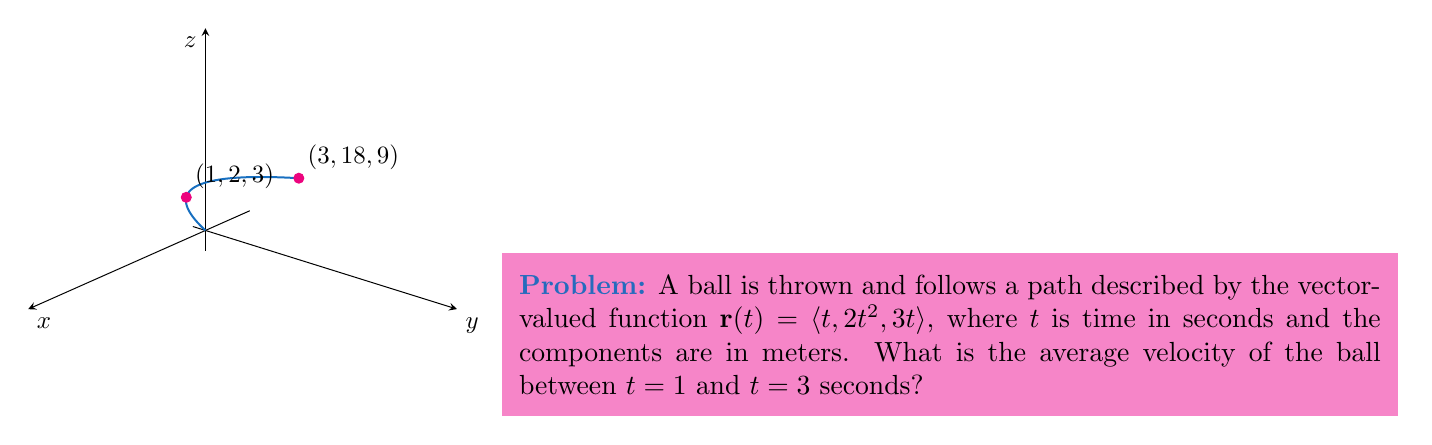Solve this math problem. To find the average velocity, we need to follow these steps:

1) The average velocity is given by the formula:
   $$\mathbf{v}_{\text{avg}} = \frac{\Delta \mathbf{r}}{\Delta t}$$
   where $\Delta \mathbf{r}$ is the displacement vector and $\Delta t$ is the time interval.

2) Calculate $\Delta t$:
   $\Delta t = t_2 - t_1 = 3 - 1 = 2$ seconds

3) Calculate $\Delta \mathbf{r}$:
   $\Delta \mathbf{r} = \mathbf{r}(3) - \mathbf{r}(1)$

4) Find $\mathbf{r}(3)$:
   $\mathbf{r}(3) = \langle 3, 2(3)^2, 3(3) \rangle = \langle 3, 18, 9 \rangle$

5) Find $\mathbf{r}(1)$:
   $\mathbf{r}(1) = \langle 1, 2(1)^2, 3(1) \rangle = \langle 1, 2, 3 \rangle$

6) Calculate $\Delta \mathbf{r}$:
   $\Delta \mathbf{r} = \langle 3, 18, 9 \rangle - \langle 1, 2, 3 \rangle = \langle 2, 16, 6 \rangle$

7) Now, calculate the average velocity:
   $$\mathbf{v}_{\text{avg}} = \frac{\Delta \mathbf{r}}{\Delta t} = \frac{\langle 2, 16, 6 \rangle}{2} = \langle 1, 8, 3 \rangle$$

Therefore, the average velocity is $\langle 1, 8, 3 \rangle$ meters per second.
Answer: $\langle 1, 8, 3 \rangle$ m/s 